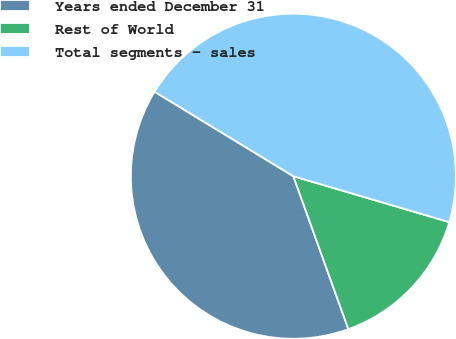<chart> <loc_0><loc_0><loc_500><loc_500><pie_chart><fcel>Years ended December 31<fcel>Rest of World<fcel>Total segments - sales<nl><fcel>39.2%<fcel>14.95%<fcel>45.85%<nl></chart> 